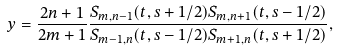Convert formula to latex. <formula><loc_0><loc_0><loc_500><loc_500>y = \frac { 2 n + 1 } { 2 m + 1 } \frac { S _ { m , n - 1 } ( t , s + 1 / 2 ) S _ { m , n + 1 } ( t , s - 1 / 2 ) } { S _ { m - 1 , n } ( t , s - 1 / 2 ) S _ { m + 1 , n } ( t , s + 1 / 2 ) } ,</formula> 